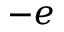Convert formula to latex. <formula><loc_0><loc_0><loc_500><loc_500>- e</formula> 